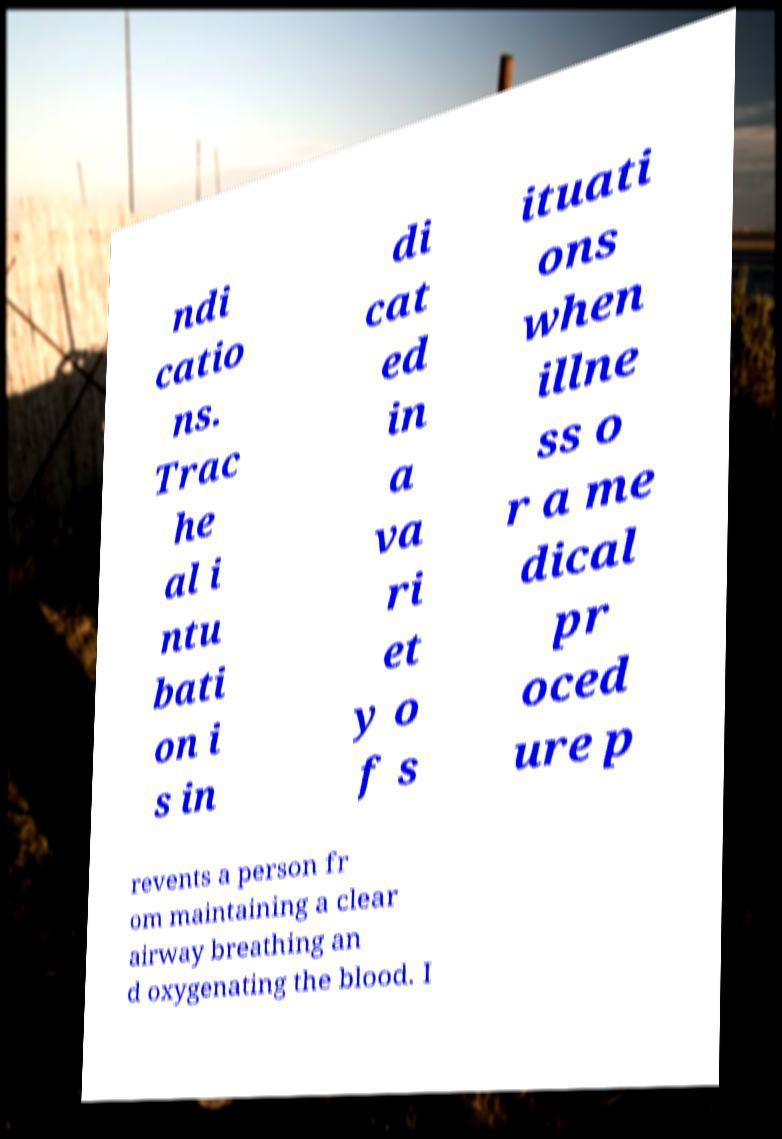Can you accurately transcribe the text from the provided image for me? ndi catio ns. Trac he al i ntu bati on i s in di cat ed in a va ri et y o f s ituati ons when illne ss o r a me dical pr oced ure p revents a person fr om maintaining a clear airway breathing an d oxygenating the blood. I 